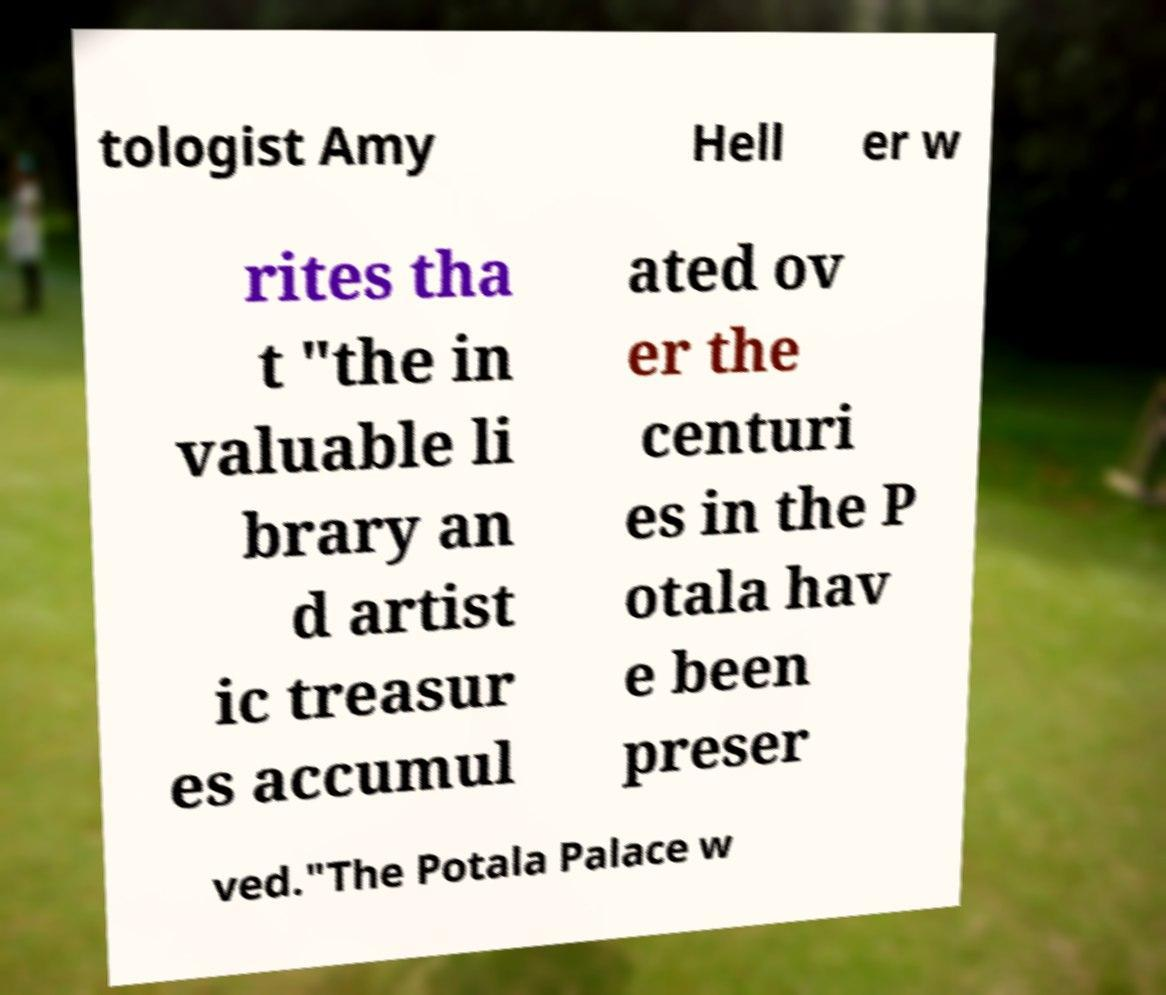I need the written content from this picture converted into text. Can you do that? tologist Amy Hell er w rites tha t "the in valuable li brary an d artist ic treasur es accumul ated ov er the centuri es in the P otala hav e been preser ved."The Potala Palace w 